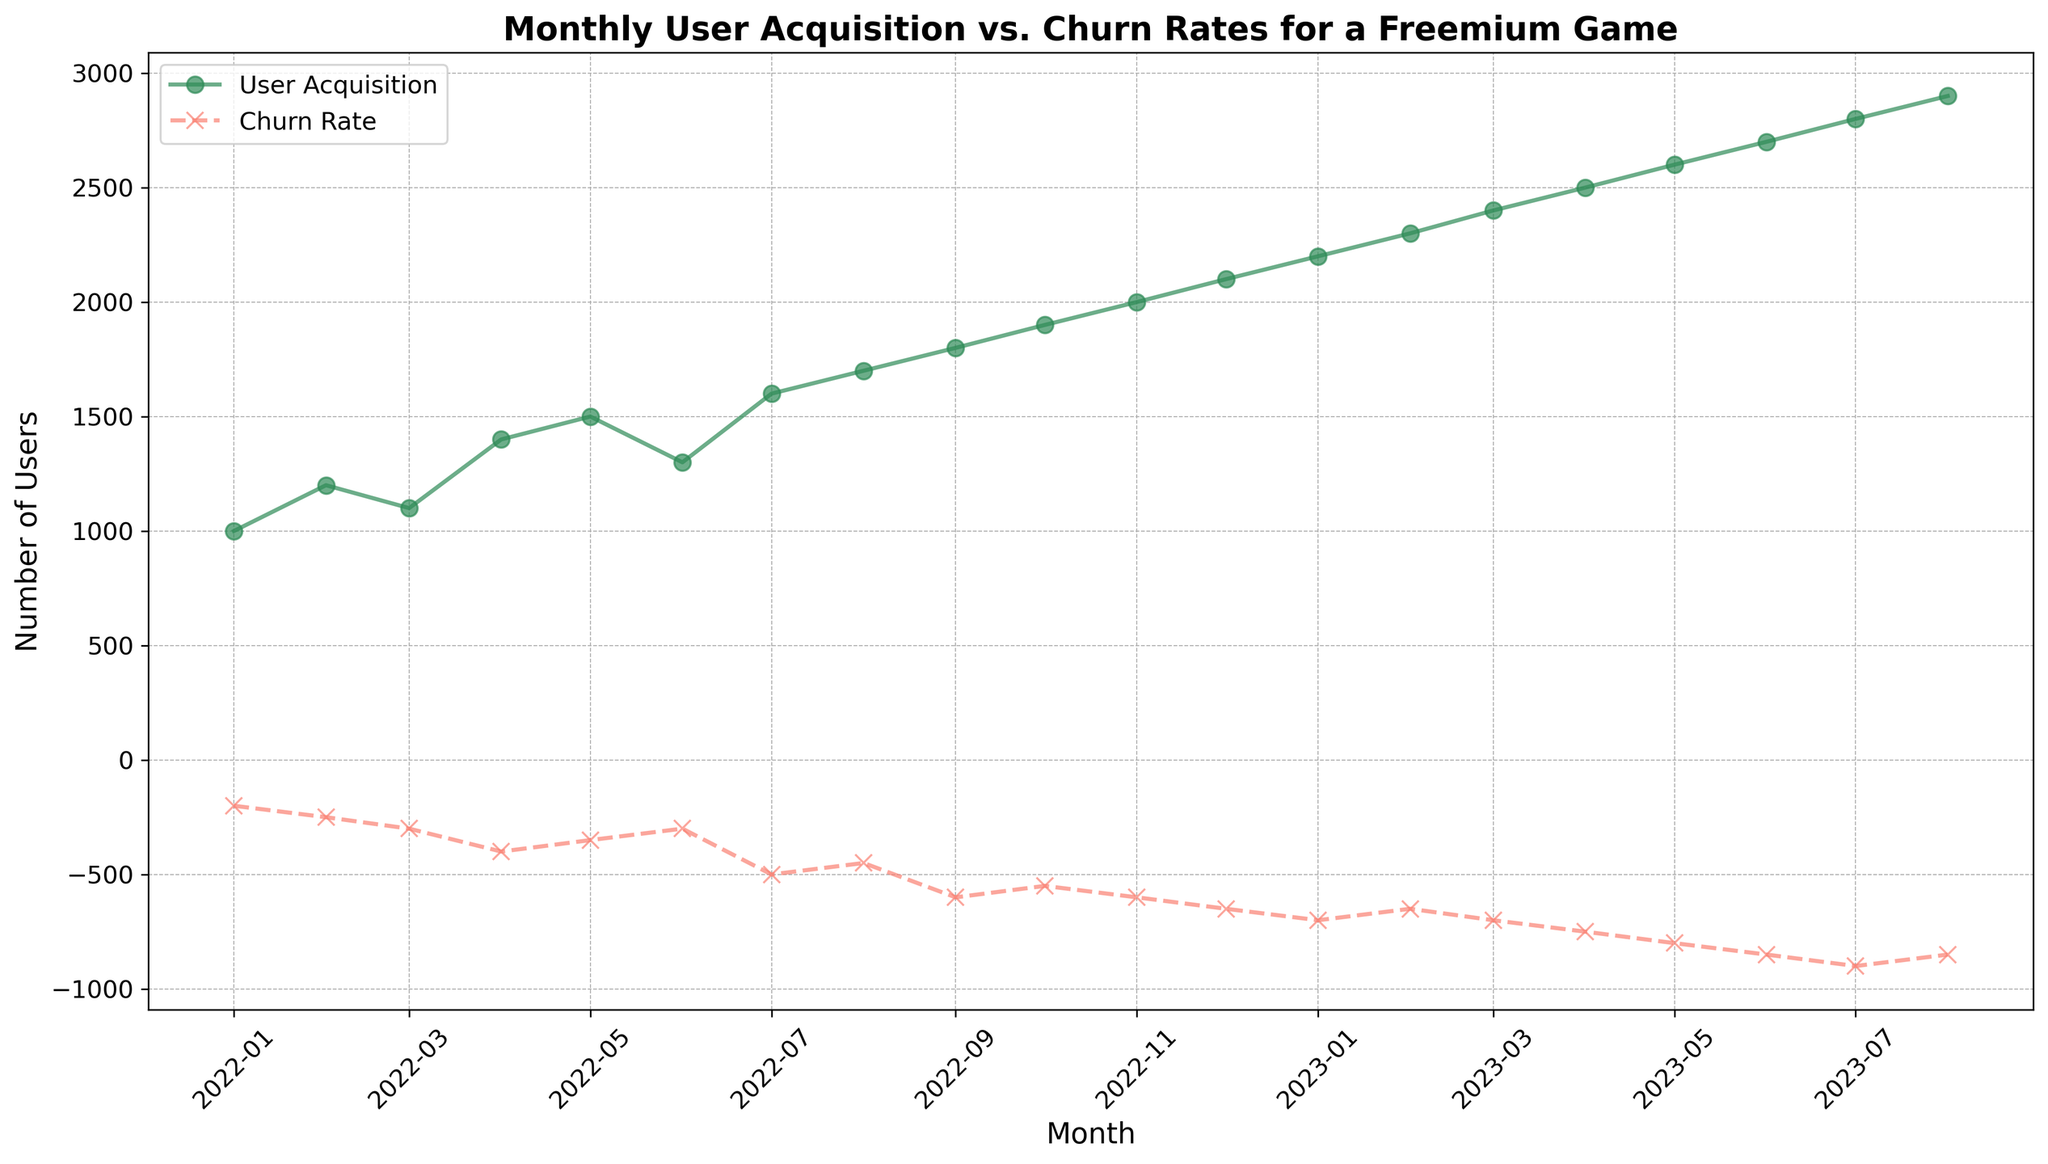What month had the highest user acquisition? By examining the green line in the plot for the highest point, we observe that July 2023 shows the highest user acquisition value.
Answer: July 2023 What is the trend in churn rate from January 2022 to August 2023? By looking at the red dashed line from January 2022 to August 2023, the churn rate value has steadily increased, indicating a rising trend in churn.
Answer: Increasing How does the user acquisition in July 2022 compare to July 2023? From the plot, July 2022 has a user acquisition value of 1600, while July 2023 has 2800. Thus, user acquisition in July 2023 is greater than in July 2022.
Answer: July 2023 is greater What is the average churn rate for the first six months of 2023? Calculate the average using the monthly churn rates for January to June 2023: (-700 -650 -700 -750 -800 -850) / 6. This gives an average churn rate of -742.
Answer: -742 Which month saw the greatest increase in user acquisition compared to the previous month? By comparing each month's user acquisition with the previous one, between April 2023 (2500) and May 2023 (2600), there is a rise of 200, the greatest observed.
Answer: May 2023 What is the difference between the total user acquisition and total churn rate for the first quarter of 2023? Sum the user acquisition: 2200 + 2300 + 2400 = 6900. Sum the churn rates: -700 -650 -700 = -2050. The difference is 6900 - (-2050) = 8950.
Answer: 8950 Is there any month where both user acquisition and churn rate values are the same? By inspecting the dashed red and solid green lines, there is no month where the values on both lines intersect or coincide.
Answer: No What visual pattern can be observed between user acquisition and churn rate? Observing both lines, as user acquisition increases, the churn rate also tends to increase, indicating a possible correlation where attracting more users also sees a rise in churn.
Answer: Both increase together Was there any month where user acquisition decreased compared to the previous month? From the plot, there are no months where the green user acquisition line dips compared to the previous months. The line consistently rises.
Answer: No By how much did the churn rate change from August 2023 compared to January 2022? Churn rate in January 2022 is -200, and in August 2023 is -850. The change is -850 - (-200) = -650, showing an increase in churn by 650.
Answer: 650 